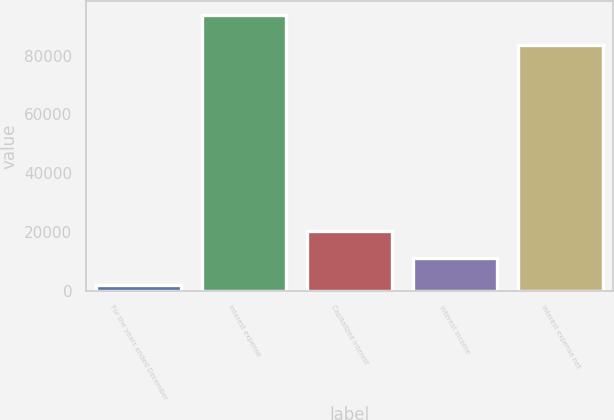<chart> <loc_0><loc_0><loc_500><loc_500><bar_chart><fcel>For the years ended December<fcel>Interest expense<fcel>Capitalized interest<fcel>Interest income<fcel>Interest expense net<nl><fcel>2014<fcel>93777<fcel>20366.6<fcel>11190.3<fcel>83532<nl></chart> 